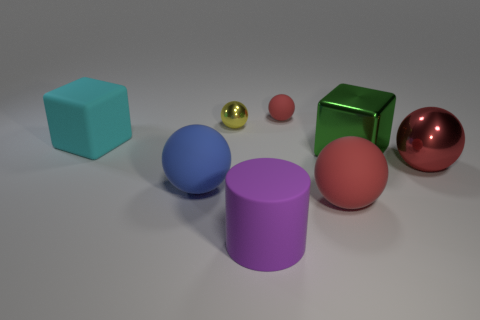Is there anything else that is the same color as the metal block?
Offer a very short reply. No. What is the material of the cube that is the same size as the cyan object?
Your answer should be very brief. Metal. The matte thing that is in front of the small yellow metallic ball and right of the purple cylinder has what shape?
Ensure brevity in your answer.  Sphere. What color is the rubber cylinder that is the same size as the green thing?
Your answer should be compact. Purple. Does the block right of the big cyan matte block have the same size as the metal ball to the left of the matte cylinder?
Ensure brevity in your answer.  No. What is the size of the cube that is on the left side of the rubber sphere left of the metallic thing that is behind the big rubber block?
Your answer should be compact. Large. The red object behind the big red ball to the right of the green metallic block is what shape?
Your answer should be very brief. Sphere. Does the matte ball that is behind the blue ball have the same color as the rubber block?
Offer a terse response. No. What is the color of the ball that is both left of the small red ball and behind the green metallic object?
Keep it short and to the point. Yellow. Are there any big cyan cubes that have the same material as the small red sphere?
Give a very brief answer. Yes. 